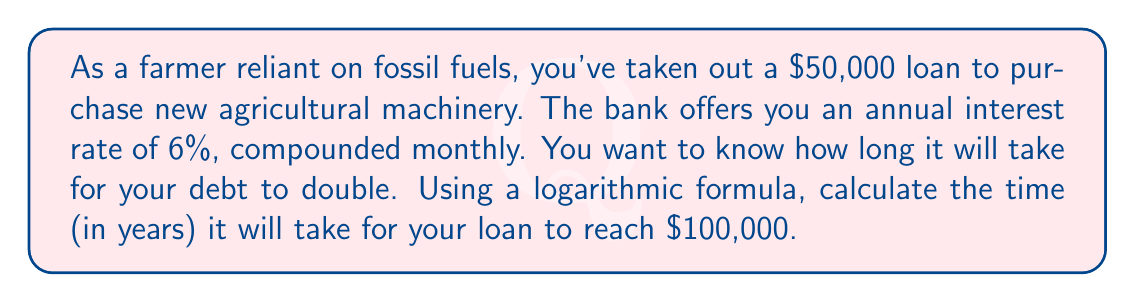What is the answer to this math problem? To solve this problem, we'll use the compound interest formula and manipulate it using logarithms:

1) The compound interest formula is:
   $A = P(1 + \frac{r}{n})^{nt}$

   Where:
   $A$ = Final amount
   $P$ = Principal (initial loan amount)
   $r$ = Annual interest rate (as a decimal)
   $n$ = Number of times interest is compounded per year
   $t$ = Time in years

2) We know:
   $A = 100,000$ (double the initial amount)
   $P = 50,000$
   $r = 0.06$ (6% as a decimal)
   $n = 12$ (compounded monthly)
   We need to solve for $t$.

3) Substituting these values:
   $100,000 = 50,000(1 + \frac{0.06}{12})^{12t}$

4) Divide both sides by 50,000:
   $2 = (1 + \frac{0.06}{12})^{12t}$

5) Take the natural log of both sides:
   $\ln(2) = 12t \ln(1 + \frac{0.06}{12})$

6) Solve for $t$:
   $t = \frac{\ln(2)}{12 \ln(1 + \frac{0.06}{12})}$

7) Calculate:
   $$t = \frac{\ln(2)}{12 \ln(1.005)} \approx 11.90 \text{ years}$$
Answer: It will take approximately 11.90 years for the loan to double to $100,000. 